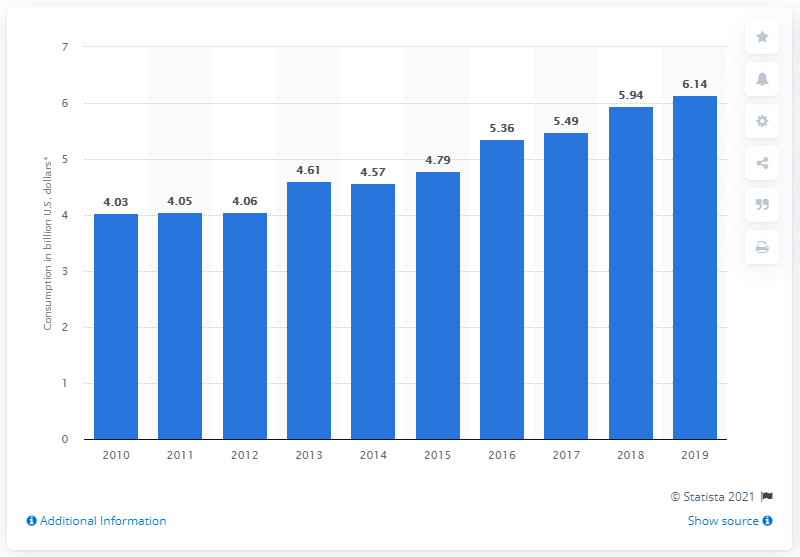Identify some key points in this picture. In 2019, the internal consumption of travel and tourism in Costa Rica reached 6.14 billion. In 2014, Costa Rica's tourism consumption began to increase. 